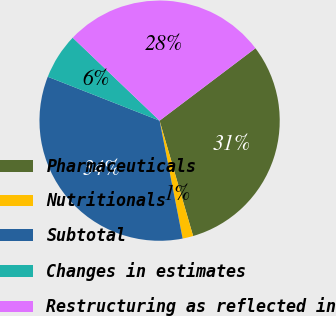Convert chart. <chart><loc_0><loc_0><loc_500><loc_500><pie_chart><fcel>Pharmaceuticals<fcel>Nutritionals<fcel>Subtotal<fcel>Changes in estimates<fcel>Restructuring as reflected in<nl><fcel>30.8%<fcel>1.43%<fcel>34.03%<fcel>6.18%<fcel>27.57%<nl></chart> 